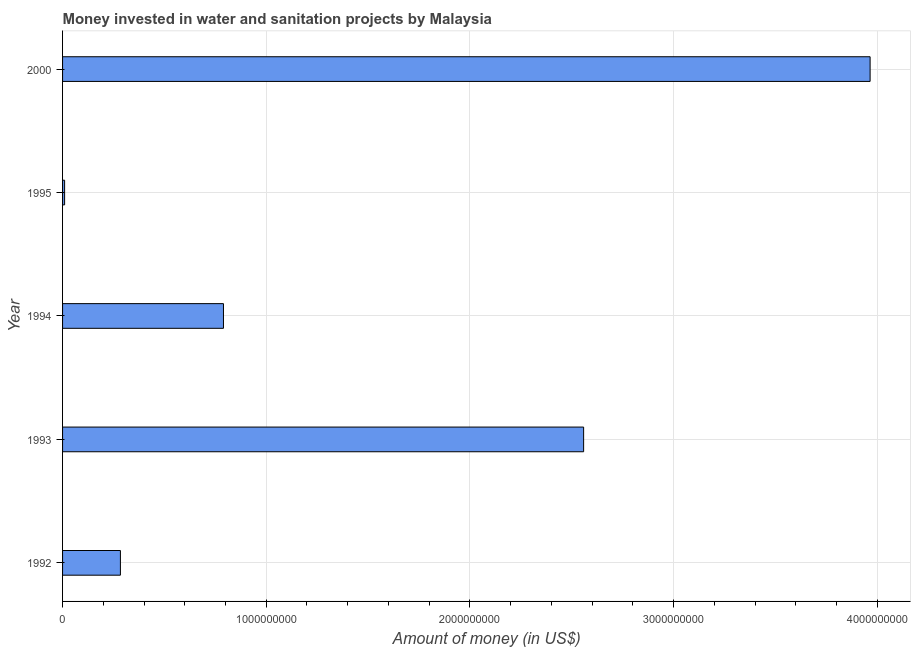Does the graph contain any zero values?
Offer a terse response. No. What is the title of the graph?
Provide a short and direct response. Money invested in water and sanitation projects by Malaysia. What is the label or title of the X-axis?
Your answer should be compact. Amount of money (in US$). What is the label or title of the Y-axis?
Make the answer very short. Year. What is the investment in 2000?
Give a very brief answer. 3.96e+09. Across all years, what is the maximum investment?
Ensure brevity in your answer.  3.96e+09. Across all years, what is the minimum investment?
Provide a succinct answer. 1.00e+07. In which year was the investment maximum?
Ensure brevity in your answer.  2000. What is the sum of the investment?
Provide a short and direct response. 7.61e+09. What is the difference between the investment in 1992 and 2000?
Your answer should be compact. -3.68e+09. What is the average investment per year?
Keep it short and to the point. 1.52e+09. What is the median investment?
Provide a succinct answer. 7.90e+08. In how many years, is the investment greater than 2600000000 US$?
Ensure brevity in your answer.  1. Do a majority of the years between 2000 and 1994 (inclusive) have investment greater than 3800000000 US$?
Give a very brief answer. Yes. What is the ratio of the investment in 1995 to that in 2000?
Provide a succinct answer. 0. Is the difference between the investment in 1993 and 1994 greater than the difference between any two years?
Offer a very short reply. No. What is the difference between the highest and the second highest investment?
Offer a terse response. 1.41e+09. What is the difference between the highest and the lowest investment?
Make the answer very short. 3.95e+09. How many bars are there?
Your response must be concise. 5. Are all the bars in the graph horizontal?
Keep it short and to the point. Yes. What is the difference between two consecutive major ticks on the X-axis?
Your answer should be very brief. 1.00e+09. Are the values on the major ticks of X-axis written in scientific E-notation?
Give a very brief answer. No. What is the Amount of money (in US$) of 1992?
Keep it short and to the point. 2.84e+08. What is the Amount of money (in US$) in 1993?
Make the answer very short. 2.56e+09. What is the Amount of money (in US$) of 1994?
Your answer should be compact. 7.90e+08. What is the Amount of money (in US$) in 1995?
Make the answer very short. 1.00e+07. What is the Amount of money (in US$) of 2000?
Keep it short and to the point. 3.96e+09. What is the difference between the Amount of money (in US$) in 1992 and 1993?
Your answer should be very brief. -2.27e+09. What is the difference between the Amount of money (in US$) in 1992 and 1994?
Keep it short and to the point. -5.06e+08. What is the difference between the Amount of money (in US$) in 1992 and 1995?
Offer a very short reply. 2.74e+08. What is the difference between the Amount of money (in US$) in 1992 and 2000?
Provide a succinct answer. -3.68e+09. What is the difference between the Amount of money (in US$) in 1993 and 1994?
Your answer should be compact. 1.77e+09. What is the difference between the Amount of money (in US$) in 1993 and 1995?
Ensure brevity in your answer.  2.55e+09. What is the difference between the Amount of money (in US$) in 1993 and 2000?
Make the answer very short. -1.41e+09. What is the difference between the Amount of money (in US$) in 1994 and 1995?
Make the answer very short. 7.80e+08. What is the difference between the Amount of money (in US$) in 1994 and 2000?
Offer a terse response. -3.17e+09. What is the difference between the Amount of money (in US$) in 1995 and 2000?
Provide a succinct answer. -3.95e+09. What is the ratio of the Amount of money (in US$) in 1992 to that in 1993?
Your answer should be very brief. 0.11. What is the ratio of the Amount of money (in US$) in 1992 to that in 1994?
Your answer should be very brief. 0.36. What is the ratio of the Amount of money (in US$) in 1992 to that in 1995?
Give a very brief answer. 28.4. What is the ratio of the Amount of money (in US$) in 1992 to that in 2000?
Provide a succinct answer. 0.07. What is the ratio of the Amount of money (in US$) in 1993 to that in 1994?
Your response must be concise. 3.24. What is the ratio of the Amount of money (in US$) in 1993 to that in 1995?
Your answer should be compact. 255.82. What is the ratio of the Amount of money (in US$) in 1993 to that in 2000?
Keep it short and to the point. 0.65. What is the ratio of the Amount of money (in US$) in 1994 to that in 1995?
Provide a short and direct response. 79. What is the ratio of the Amount of money (in US$) in 1994 to that in 2000?
Offer a very short reply. 0.2. What is the ratio of the Amount of money (in US$) in 1995 to that in 2000?
Keep it short and to the point. 0. 